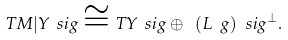Convert formula to latex. <formula><loc_0><loc_0><loc_500><loc_500>T M | Y _ { \ } s i g \cong T Y _ { \ } s i g \oplus \ ( L \ g ) _ { \ } s i g ^ { \perp } .</formula> 